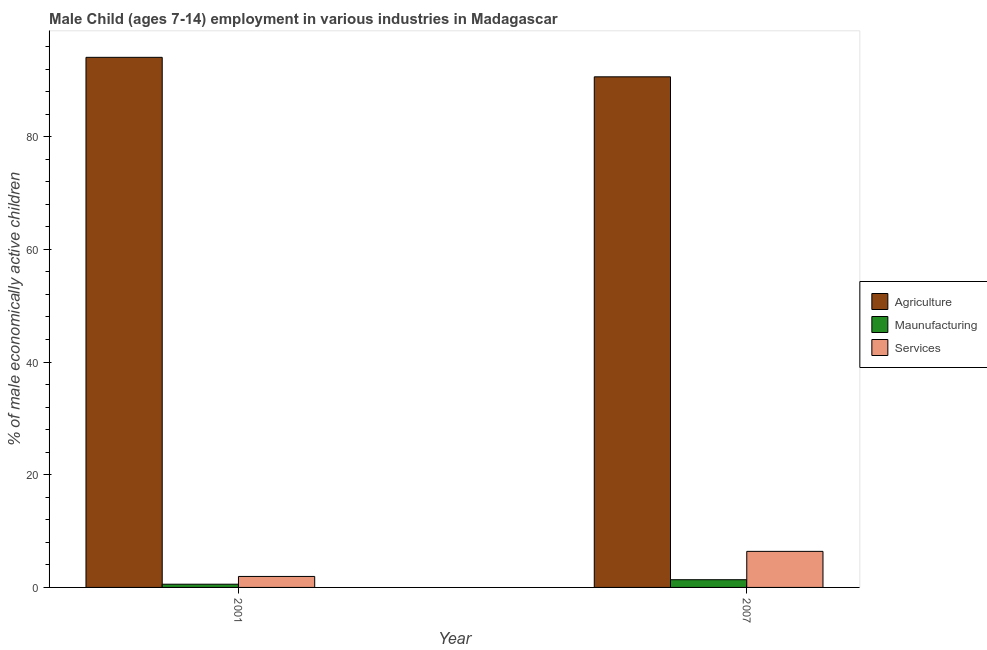How many different coloured bars are there?
Make the answer very short. 3. How many bars are there on the 1st tick from the left?
Keep it short and to the point. 3. How many bars are there on the 1st tick from the right?
Make the answer very short. 3. What is the percentage of economically active children in agriculture in 2001?
Ensure brevity in your answer.  94.08. Across all years, what is the minimum percentage of economically active children in services?
Provide a succinct answer. 1.95. In which year was the percentage of economically active children in manufacturing maximum?
Ensure brevity in your answer.  2007. In which year was the percentage of economically active children in manufacturing minimum?
Your answer should be compact. 2001. What is the total percentage of economically active children in services in the graph?
Your answer should be very brief. 8.35. What is the difference between the percentage of economically active children in services in 2001 and that in 2007?
Keep it short and to the point. -4.45. What is the difference between the percentage of economically active children in manufacturing in 2007 and the percentage of economically active children in agriculture in 2001?
Your answer should be compact. 0.8. What is the ratio of the percentage of economically active children in agriculture in 2001 to that in 2007?
Provide a short and direct response. 1.04. Is the percentage of economically active children in services in 2001 less than that in 2007?
Keep it short and to the point. Yes. What does the 2nd bar from the left in 2007 represents?
Give a very brief answer. Maunufacturing. What does the 1st bar from the right in 2007 represents?
Your answer should be compact. Services. Is it the case that in every year, the sum of the percentage of economically active children in agriculture and percentage of economically active children in manufacturing is greater than the percentage of economically active children in services?
Offer a very short reply. Yes. Are all the bars in the graph horizontal?
Offer a terse response. No. What is the difference between two consecutive major ticks on the Y-axis?
Offer a terse response. 20. Are the values on the major ticks of Y-axis written in scientific E-notation?
Offer a terse response. No. Does the graph contain any zero values?
Your response must be concise. No. How many legend labels are there?
Give a very brief answer. 3. What is the title of the graph?
Offer a very short reply. Male Child (ages 7-14) employment in various industries in Madagascar. Does "Self-employed" appear as one of the legend labels in the graph?
Your response must be concise. No. What is the label or title of the Y-axis?
Ensure brevity in your answer.  % of male economically active children. What is the % of male economically active children of Agriculture in 2001?
Your answer should be very brief. 94.08. What is the % of male economically active children of Maunufacturing in 2001?
Give a very brief answer. 0.57. What is the % of male economically active children in Services in 2001?
Keep it short and to the point. 1.95. What is the % of male economically active children in Agriculture in 2007?
Provide a short and direct response. 90.62. What is the % of male economically active children of Maunufacturing in 2007?
Keep it short and to the point. 1.37. Across all years, what is the maximum % of male economically active children of Agriculture?
Offer a very short reply. 94.08. Across all years, what is the maximum % of male economically active children of Maunufacturing?
Ensure brevity in your answer.  1.37. Across all years, what is the minimum % of male economically active children in Agriculture?
Give a very brief answer. 90.62. Across all years, what is the minimum % of male economically active children of Maunufacturing?
Give a very brief answer. 0.57. Across all years, what is the minimum % of male economically active children in Services?
Your answer should be very brief. 1.95. What is the total % of male economically active children in Agriculture in the graph?
Make the answer very short. 184.7. What is the total % of male economically active children in Maunufacturing in the graph?
Keep it short and to the point. 1.94. What is the total % of male economically active children of Services in the graph?
Offer a very short reply. 8.35. What is the difference between the % of male economically active children in Agriculture in 2001 and that in 2007?
Make the answer very short. 3.46. What is the difference between the % of male economically active children of Services in 2001 and that in 2007?
Offer a terse response. -4.45. What is the difference between the % of male economically active children in Agriculture in 2001 and the % of male economically active children in Maunufacturing in 2007?
Ensure brevity in your answer.  92.71. What is the difference between the % of male economically active children in Agriculture in 2001 and the % of male economically active children in Services in 2007?
Give a very brief answer. 87.68. What is the difference between the % of male economically active children in Maunufacturing in 2001 and the % of male economically active children in Services in 2007?
Give a very brief answer. -5.83. What is the average % of male economically active children in Agriculture per year?
Your response must be concise. 92.35. What is the average % of male economically active children of Services per year?
Offer a very short reply. 4.17. In the year 2001, what is the difference between the % of male economically active children of Agriculture and % of male economically active children of Maunufacturing?
Make the answer very short. 93.51. In the year 2001, what is the difference between the % of male economically active children in Agriculture and % of male economically active children in Services?
Make the answer very short. 92.13. In the year 2001, what is the difference between the % of male economically active children in Maunufacturing and % of male economically active children in Services?
Your answer should be very brief. -1.38. In the year 2007, what is the difference between the % of male economically active children of Agriculture and % of male economically active children of Maunufacturing?
Your response must be concise. 89.25. In the year 2007, what is the difference between the % of male economically active children in Agriculture and % of male economically active children in Services?
Offer a terse response. 84.22. In the year 2007, what is the difference between the % of male economically active children in Maunufacturing and % of male economically active children in Services?
Provide a short and direct response. -5.03. What is the ratio of the % of male economically active children in Agriculture in 2001 to that in 2007?
Give a very brief answer. 1.04. What is the ratio of the % of male economically active children in Maunufacturing in 2001 to that in 2007?
Give a very brief answer. 0.42. What is the ratio of the % of male economically active children in Services in 2001 to that in 2007?
Your answer should be compact. 0.3. What is the difference between the highest and the second highest % of male economically active children in Agriculture?
Provide a succinct answer. 3.46. What is the difference between the highest and the second highest % of male economically active children of Maunufacturing?
Your answer should be compact. 0.8. What is the difference between the highest and the second highest % of male economically active children of Services?
Your response must be concise. 4.45. What is the difference between the highest and the lowest % of male economically active children in Agriculture?
Offer a terse response. 3.46. What is the difference between the highest and the lowest % of male economically active children of Services?
Ensure brevity in your answer.  4.45. 